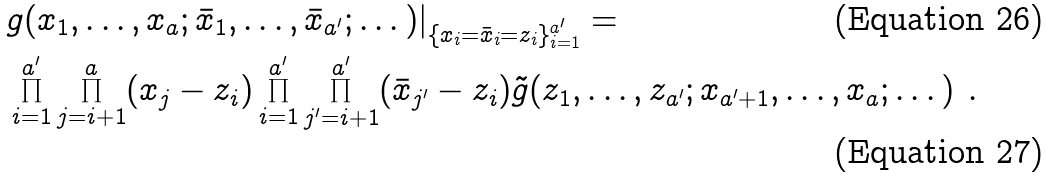Convert formula to latex. <formula><loc_0><loc_0><loc_500><loc_500>& { g } ( x _ { 1 } , \dots , x _ { a } ; \bar { x } _ { 1 } , \dots , \bar { x } _ { a ^ { \prime } } ; \dots ) | _ { \{ x _ { i } = \bar { x } _ { i } = z _ { i } \} _ { i = 1 } ^ { a ^ { \prime } } } = \\ & \prod _ { i = 1 } ^ { a ^ { \prime } } \prod _ { j = i + 1 } ^ { a } ( x _ { j } - z _ { i } ) \prod _ { i = 1 } ^ { a ^ { \prime } } \prod _ { j ^ { \prime } = i + 1 } ^ { a ^ { \prime } } ( \bar { x } _ { j ^ { \prime } } - z _ { i } ) \tilde { g } ( z _ { 1 } , \dots , z _ { a ^ { \prime } } ; x _ { a ^ { \prime } + 1 } , \dots , x _ { a } ; \dots ) \ .</formula> 